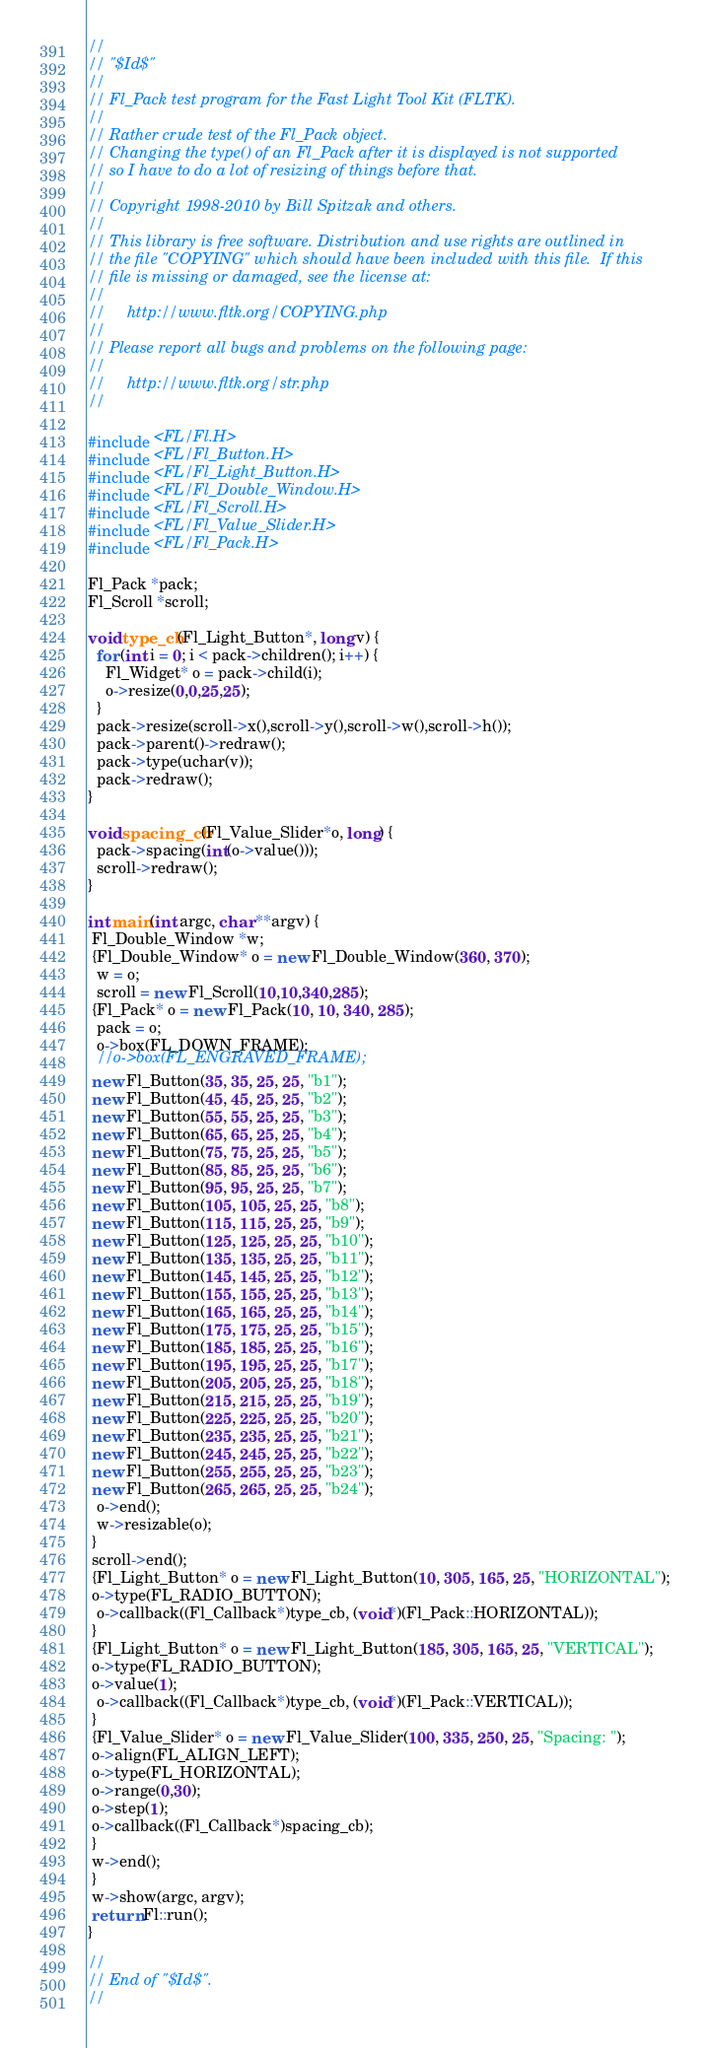Convert code to text. <code><loc_0><loc_0><loc_500><loc_500><_C++_>//
// "$Id$"
//
// Fl_Pack test program for the Fast Light Tool Kit (FLTK).
//
// Rather crude test of the Fl_Pack object.
// Changing the type() of an Fl_Pack after it is displayed is not supported
// so I have to do a lot of resizing of things before that.
//
// Copyright 1998-2010 by Bill Spitzak and others.
//
// This library is free software. Distribution and use rights are outlined in
// the file "COPYING" which should have been included with this file.  If this
// file is missing or damaged, see the license at:
//
//     http://www.fltk.org/COPYING.php
//
// Please report all bugs and problems on the following page:
//
//     http://www.fltk.org/str.php
//

#include <FL/Fl.H>
#include <FL/Fl_Button.H>
#include <FL/Fl_Light_Button.H>
#include <FL/Fl_Double_Window.H>
#include <FL/Fl_Scroll.H>
#include <FL/Fl_Value_Slider.H>
#include <FL/Fl_Pack.H>

Fl_Pack *pack;
Fl_Scroll *scroll;

void type_cb(Fl_Light_Button*, long v) {
  for (int i = 0; i < pack->children(); i++) {
    Fl_Widget* o = pack->child(i);
    o->resize(0,0,25,25);
  }
  pack->resize(scroll->x(),scroll->y(),scroll->w(),scroll->h());
  pack->parent()->redraw();
  pack->type(uchar(v));
  pack->redraw();
}

void spacing_cb(Fl_Value_Slider*o, long) {
  pack->spacing(int(o->value()));
  scroll->redraw();
}

int main(int argc, char **argv) {
 Fl_Double_Window *w;
 {Fl_Double_Window* o = new Fl_Double_Window(360, 370);
  w = o;
  scroll = new Fl_Scroll(10,10,340,285);
 {Fl_Pack* o = new Fl_Pack(10, 10, 340, 285);
  pack = o;
  o->box(FL_DOWN_FRAME);
  //o->box(FL_ENGRAVED_FRAME);
 new Fl_Button(35, 35, 25, 25, "b1");
 new Fl_Button(45, 45, 25, 25, "b2");
 new Fl_Button(55, 55, 25, 25, "b3");
 new Fl_Button(65, 65, 25, 25, "b4");
 new Fl_Button(75, 75, 25, 25, "b5");
 new Fl_Button(85, 85, 25, 25, "b6");
 new Fl_Button(95, 95, 25, 25, "b7");
 new Fl_Button(105, 105, 25, 25, "b8");
 new Fl_Button(115, 115, 25, 25, "b9");
 new Fl_Button(125, 125, 25, 25, "b10");
 new Fl_Button(135, 135, 25, 25, "b11");
 new Fl_Button(145, 145, 25, 25, "b12");
 new Fl_Button(155, 155, 25, 25, "b13");
 new Fl_Button(165, 165, 25, 25, "b14");
 new Fl_Button(175, 175, 25, 25, "b15");
 new Fl_Button(185, 185, 25, 25, "b16");
 new Fl_Button(195, 195, 25, 25, "b17");
 new Fl_Button(205, 205, 25, 25, "b18");
 new Fl_Button(215, 215, 25, 25, "b19");
 new Fl_Button(225, 225, 25, 25, "b20");
 new Fl_Button(235, 235, 25, 25, "b21");
 new Fl_Button(245, 245, 25, 25, "b22");
 new Fl_Button(255, 255, 25, 25, "b23");
 new Fl_Button(265, 265, 25, 25, "b24");
  o->end();
  w->resizable(o);
 }
 scroll->end();
 {Fl_Light_Button* o = new Fl_Light_Button(10, 305, 165, 25, "HORIZONTAL");
 o->type(FL_RADIO_BUTTON);
  o->callback((Fl_Callback*)type_cb, (void*)(Fl_Pack::HORIZONTAL));
 }
 {Fl_Light_Button* o = new Fl_Light_Button(185, 305, 165, 25, "VERTICAL");
 o->type(FL_RADIO_BUTTON);
 o->value(1);
  o->callback((Fl_Callback*)type_cb, (void*)(Fl_Pack::VERTICAL));
 }
 {Fl_Value_Slider* o = new Fl_Value_Slider(100, 335, 250, 25, "Spacing: ");
 o->align(FL_ALIGN_LEFT);
 o->type(FL_HORIZONTAL);
 o->range(0,30);
 o->step(1);
 o->callback((Fl_Callback*)spacing_cb);
 }
 w->end();
 }
 w->show(argc, argv);
 return Fl::run();
}

//
// End of "$Id$".
//
</code> 